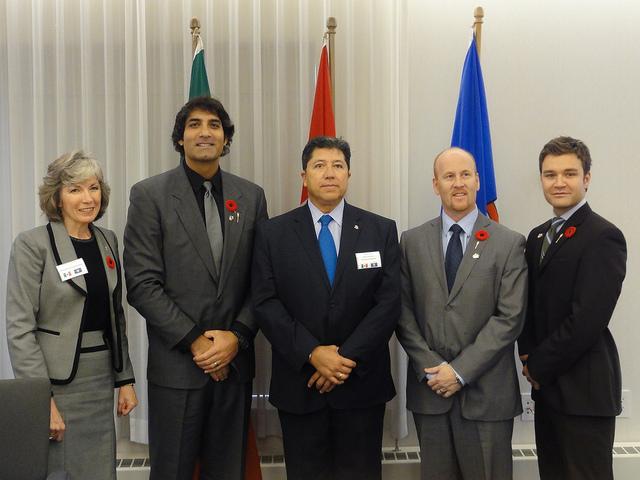Is this a business meeting?
Keep it brief. Yes. How many men are in the picture?
Answer briefly. 4. How many flags appear?
Quick response, please. 3. Why is the guy to the left taller?
Concise answer only. Genetics. 